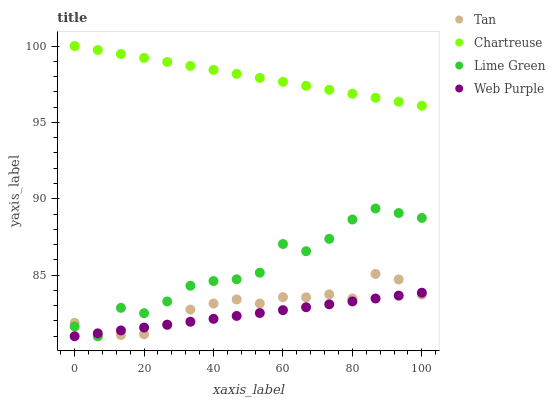Does Web Purple have the minimum area under the curve?
Answer yes or no. Yes. Does Chartreuse have the maximum area under the curve?
Answer yes or no. Yes. Does Tan have the minimum area under the curve?
Answer yes or no. No. Does Tan have the maximum area under the curve?
Answer yes or no. No. Is Web Purple the smoothest?
Answer yes or no. Yes. Is Lime Green the roughest?
Answer yes or no. Yes. Is Tan the smoothest?
Answer yes or no. No. Is Tan the roughest?
Answer yes or no. No. Does Web Purple have the lowest value?
Answer yes or no. Yes. Does Chartreuse have the lowest value?
Answer yes or no. No. Does Chartreuse have the highest value?
Answer yes or no. Yes. Does Tan have the highest value?
Answer yes or no. No. Is Lime Green less than Chartreuse?
Answer yes or no. Yes. Is Chartreuse greater than Tan?
Answer yes or no. Yes. Does Web Purple intersect Tan?
Answer yes or no. Yes. Is Web Purple less than Tan?
Answer yes or no. No. Is Web Purple greater than Tan?
Answer yes or no. No. Does Lime Green intersect Chartreuse?
Answer yes or no. No. 